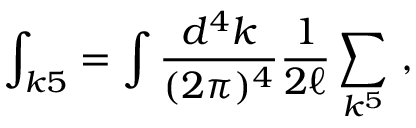Convert formula to latex. <formula><loc_0><loc_0><loc_500><loc_500>\int _ { k 5 } = \int { \frac { d ^ { 4 } k } { ( 2 \pi ) ^ { 4 } } } { \frac { 1 } { 2 \ell } } \sum _ { k ^ { 5 } } \ ,</formula> 